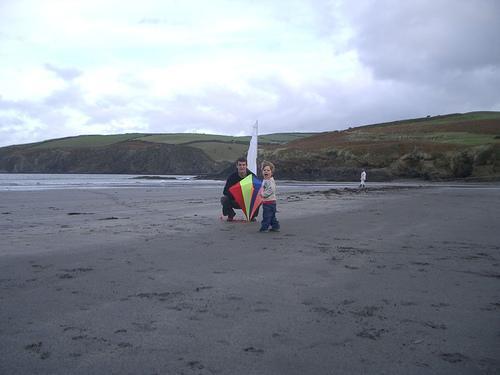What will this child hold while they play with this toy?
Select the accurate answer and provide justification: `Answer: choice
Rationale: srationale.`
Options: Tail, drone, string, control. Answer: string.
Rationale: The child will have the string. 